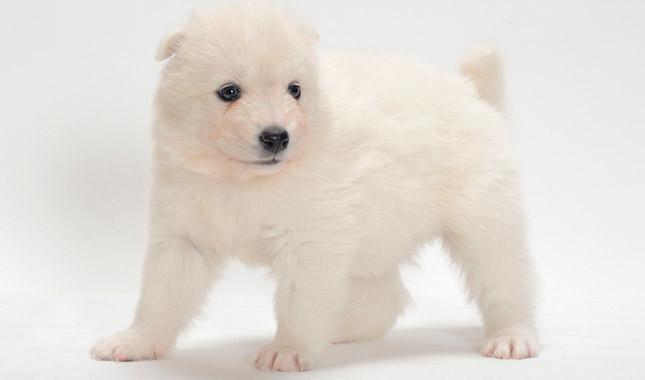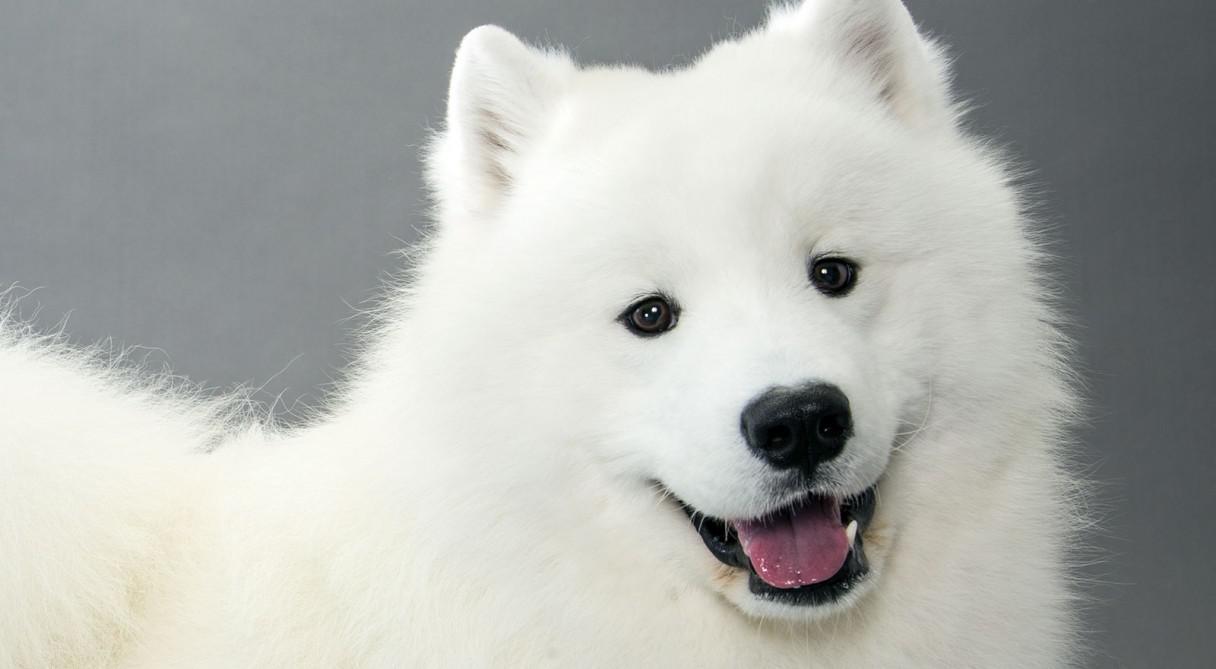The first image is the image on the left, the second image is the image on the right. For the images shown, is this caption "The dogs appear to be facing each other." true? Answer yes or no. No. 